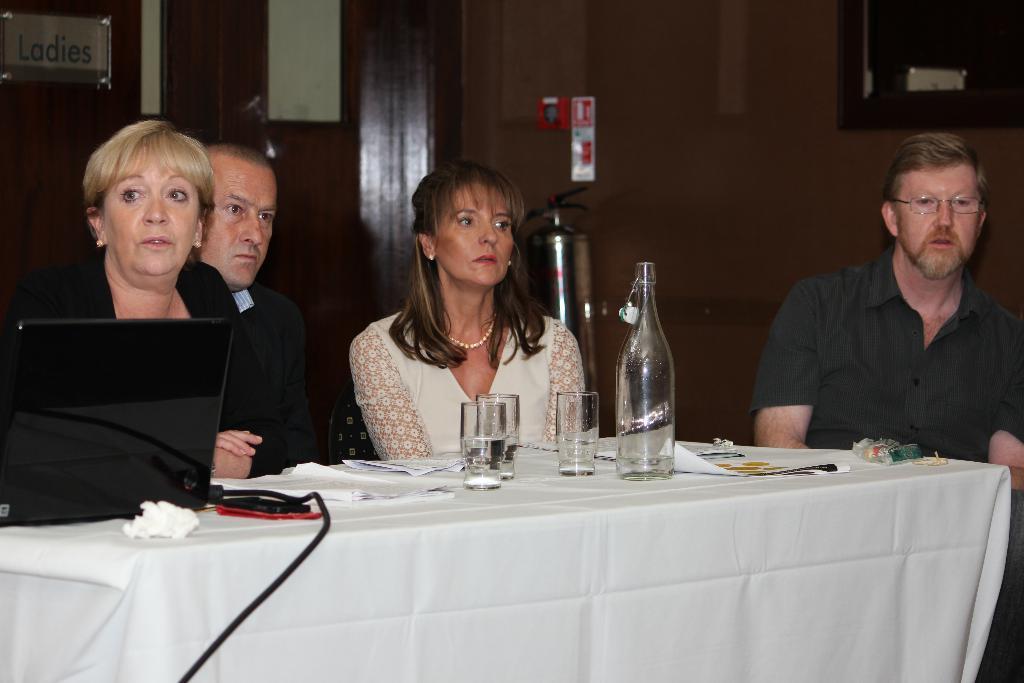Please provide a concise description of this image. There are a four people who are sitting on a chair and looking at someone. This is a table where a glass, a bottle and a laptop are kept on it. 